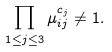<formula> <loc_0><loc_0><loc_500><loc_500>\prod _ { 1 \leq j \leq 3 } \mu _ { i j } ^ { c _ { j } } \neq 1 .</formula> 